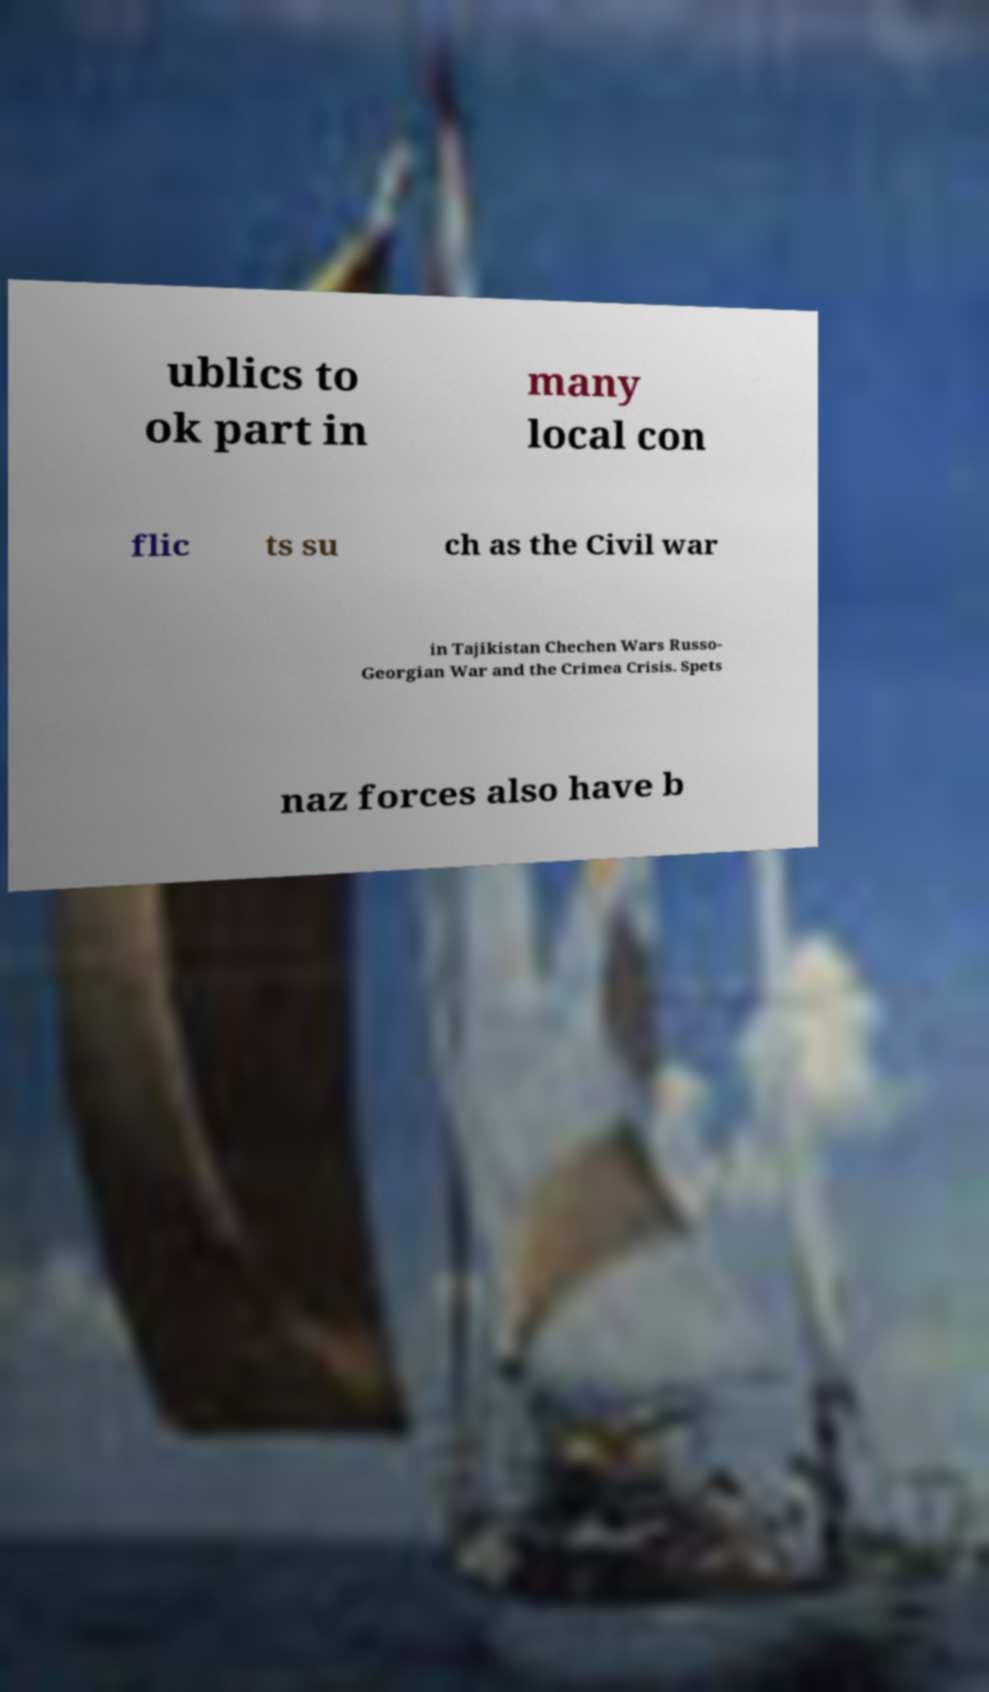Can you read and provide the text displayed in the image?This photo seems to have some interesting text. Can you extract and type it out for me? ublics to ok part in many local con flic ts su ch as the Civil war in Tajikistan Chechen Wars Russo- Georgian War and the Crimea Crisis. Spets naz forces also have b 